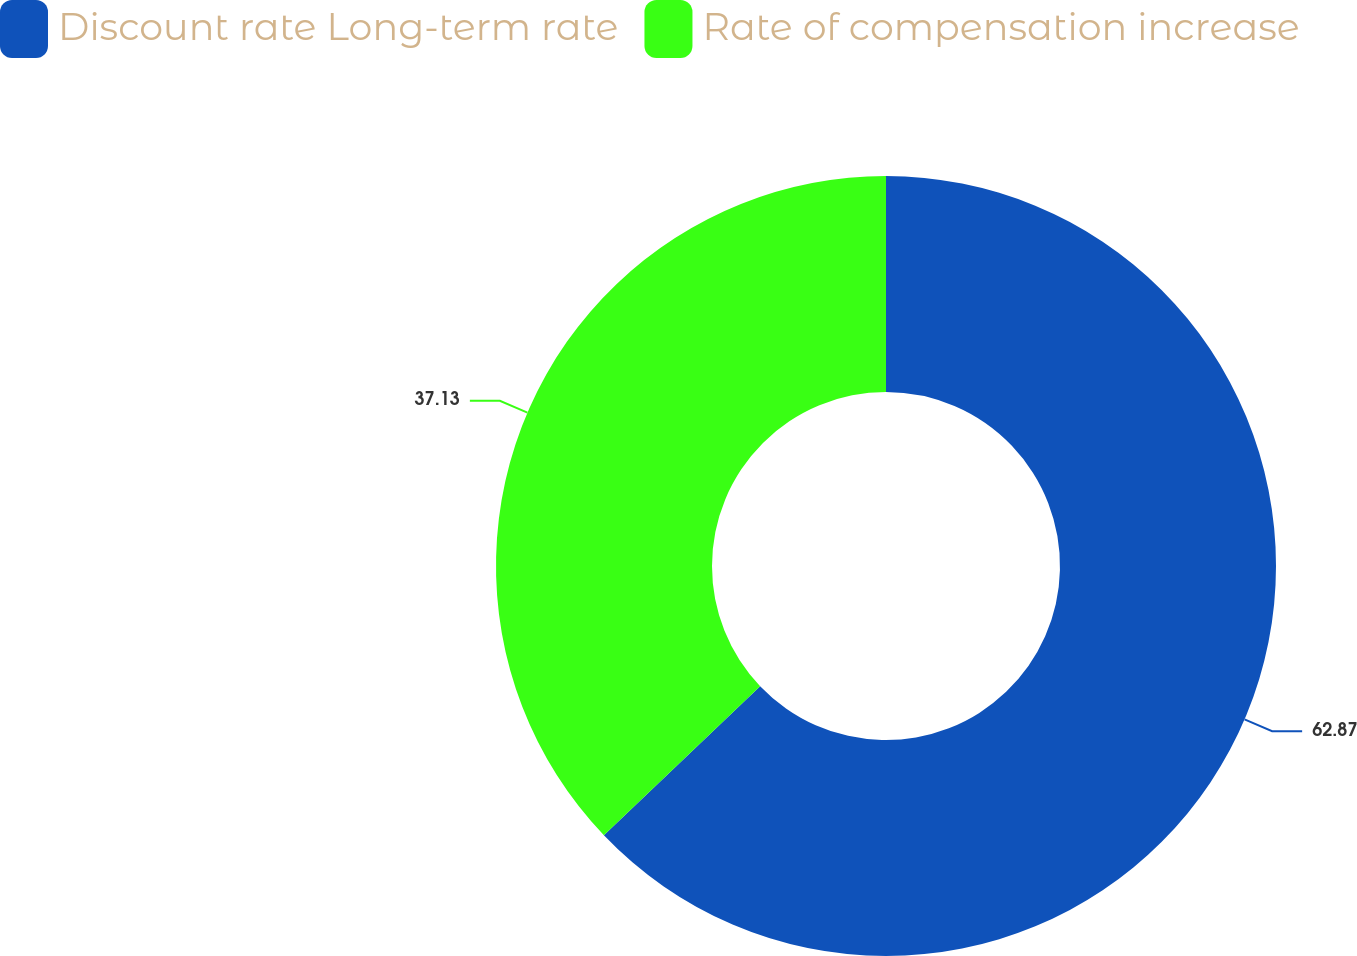Convert chart. <chart><loc_0><loc_0><loc_500><loc_500><pie_chart><fcel>Discount rate Long-term rate<fcel>Rate of compensation increase<nl><fcel>62.87%<fcel>37.13%<nl></chart> 